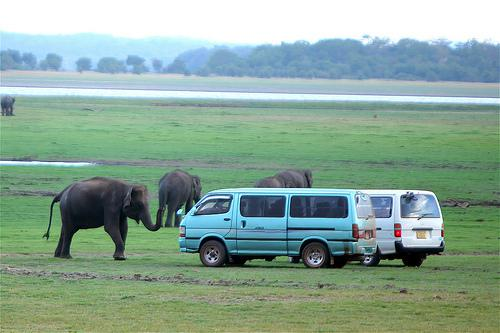Question: how many people can you see?
Choices:
A. One.
B. Zero.
C. Two.
D. Three.
Answer with the letter. Answer: B Question: what type of vehicles are these?
Choices:
A. Tractor.
B. Rv.
C. Toy hauler.
D. Vans.
Answer with the letter. Answer: D Question: what kind of anmals are these?
Choices:
A. Penguins.
B. Monkeys.
C. Elephants.
D. Goats.
Answer with the letter. Answer: C Question: what is the ground surface?
Choices:
A. Turf.
B. Cement.
C. Tar.
D. Grass.
Answer with the letter. Answer: D Question: when was the photo taken?
Choices:
A. On halloween.
B. At christmas.
C. New years.
D. Daylight.
Answer with the letter. Answer: D Question: where was the photo taken?
Choices:
A. Wildlife park.
B. In a clearing.
C. At a zoo.
D. In the forest.
Answer with the letter. Answer: A 